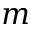<formula> <loc_0><loc_0><loc_500><loc_500>m</formula> 